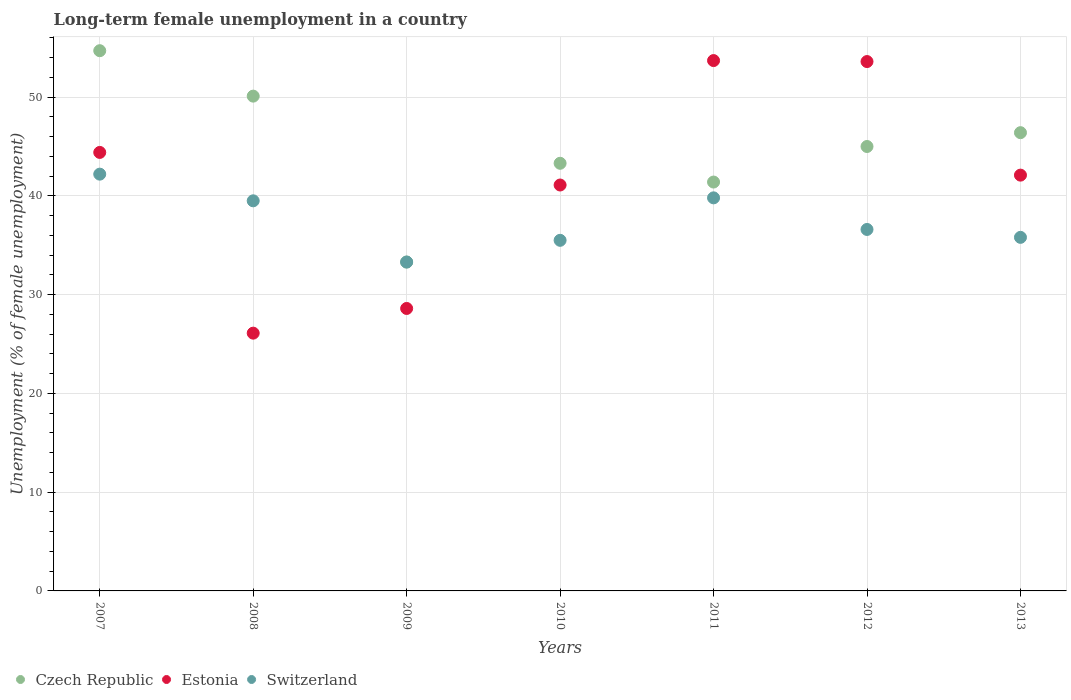How many different coloured dotlines are there?
Make the answer very short. 3. Is the number of dotlines equal to the number of legend labels?
Ensure brevity in your answer.  Yes. What is the percentage of long-term unemployed female population in Estonia in 2013?
Your response must be concise. 42.1. Across all years, what is the maximum percentage of long-term unemployed female population in Czech Republic?
Provide a succinct answer. 54.7. Across all years, what is the minimum percentage of long-term unemployed female population in Switzerland?
Provide a short and direct response. 33.3. In which year was the percentage of long-term unemployed female population in Estonia minimum?
Offer a terse response. 2008. What is the total percentage of long-term unemployed female population in Estonia in the graph?
Provide a succinct answer. 289.6. What is the difference between the percentage of long-term unemployed female population in Switzerland in 2009 and that in 2011?
Offer a terse response. -6.5. What is the difference between the percentage of long-term unemployed female population in Czech Republic in 2007 and the percentage of long-term unemployed female population in Switzerland in 2012?
Provide a succinct answer. 18.1. What is the average percentage of long-term unemployed female population in Czech Republic per year?
Make the answer very short. 44.89. In the year 2009, what is the difference between the percentage of long-term unemployed female population in Switzerland and percentage of long-term unemployed female population in Czech Republic?
Your answer should be compact. 0. In how many years, is the percentage of long-term unemployed female population in Estonia greater than 54 %?
Your answer should be very brief. 0. What is the ratio of the percentage of long-term unemployed female population in Czech Republic in 2010 to that in 2012?
Offer a very short reply. 0.96. What is the difference between the highest and the second highest percentage of long-term unemployed female population in Switzerland?
Provide a succinct answer. 2.4. What is the difference between the highest and the lowest percentage of long-term unemployed female population in Estonia?
Make the answer very short. 27.6. In how many years, is the percentage of long-term unemployed female population in Switzerland greater than the average percentage of long-term unemployed female population in Switzerland taken over all years?
Provide a succinct answer. 3. Is the percentage of long-term unemployed female population in Estonia strictly greater than the percentage of long-term unemployed female population in Switzerland over the years?
Provide a succinct answer. No. Is the percentage of long-term unemployed female population in Estonia strictly less than the percentage of long-term unemployed female population in Czech Republic over the years?
Give a very brief answer. No. How many years are there in the graph?
Keep it short and to the point. 7. Are the values on the major ticks of Y-axis written in scientific E-notation?
Offer a terse response. No. Does the graph contain any zero values?
Provide a succinct answer. No. Where does the legend appear in the graph?
Give a very brief answer. Bottom left. How many legend labels are there?
Offer a very short reply. 3. What is the title of the graph?
Make the answer very short. Long-term female unemployment in a country. What is the label or title of the X-axis?
Provide a succinct answer. Years. What is the label or title of the Y-axis?
Provide a succinct answer. Unemployment (% of female unemployment). What is the Unemployment (% of female unemployment) in Czech Republic in 2007?
Offer a very short reply. 54.7. What is the Unemployment (% of female unemployment) in Estonia in 2007?
Provide a succinct answer. 44.4. What is the Unemployment (% of female unemployment) of Switzerland in 2007?
Provide a short and direct response. 42.2. What is the Unemployment (% of female unemployment) in Czech Republic in 2008?
Offer a terse response. 50.1. What is the Unemployment (% of female unemployment) in Estonia in 2008?
Make the answer very short. 26.1. What is the Unemployment (% of female unemployment) in Switzerland in 2008?
Ensure brevity in your answer.  39.5. What is the Unemployment (% of female unemployment) in Czech Republic in 2009?
Keep it short and to the point. 33.3. What is the Unemployment (% of female unemployment) in Estonia in 2009?
Make the answer very short. 28.6. What is the Unemployment (% of female unemployment) in Switzerland in 2009?
Ensure brevity in your answer.  33.3. What is the Unemployment (% of female unemployment) in Czech Republic in 2010?
Provide a short and direct response. 43.3. What is the Unemployment (% of female unemployment) of Estonia in 2010?
Offer a very short reply. 41.1. What is the Unemployment (% of female unemployment) in Switzerland in 2010?
Keep it short and to the point. 35.5. What is the Unemployment (% of female unemployment) of Czech Republic in 2011?
Your answer should be very brief. 41.4. What is the Unemployment (% of female unemployment) of Estonia in 2011?
Ensure brevity in your answer.  53.7. What is the Unemployment (% of female unemployment) of Switzerland in 2011?
Offer a terse response. 39.8. What is the Unemployment (% of female unemployment) in Czech Republic in 2012?
Your answer should be compact. 45. What is the Unemployment (% of female unemployment) of Estonia in 2012?
Provide a short and direct response. 53.6. What is the Unemployment (% of female unemployment) of Switzerland in 2012?
Your answer should be very brief. 36.6. What is the Unemployment (% of female unemployment) of Czech Republic in 2013?
Offer a terse response. 46.4. What is the Unemployment (% of female unemployment) of Estonia in 2013?
Offer a very short reply. 42.1. What is the Unemployment (% of female unemployment) in Switzerland in 2013?
Your answer should be compact. 35.8. Across all years, what is the maximum Unemployment (% of female unemployment) of Czech Republic?
Provide a succinct answer. 54.7. Across all years, what is the maximum Unemployment (% of female unemployment) in Estonia?
Provide a short and direct response. 53.7. Across all years, what is the maximum Unemployment (% of female unemployment) in Switzerland?
Ensure brevity in your answer.  42.2. Across all years, what is the minimum Unemployment (% of female unemployment) in Czech Republic?
Provide a short and direct response. 33.3. Across all years, what is the minimum Unemployment (% of female unemployment) of Estonia?
Your answer should be compact. 26.1. Across all years, what is the minimum Unemployment (% of female unemployment) in Switzerland?
Your response must be concise. 33.3. What is the total Unemployment (% of female unemployment) in Czech Republic in the graph?
Your answer should be very brief. 314.2. What is the total Unemployment (% of female unemployment) in Estonia in the graph?
Ensure brevity in your answer.  289.6. What is the total Unemployment (% of female unemployment) of Switzerland in the graph?
Offer a terse response. 262.7. What is the difference between the Unemployment (% of female unemployment) in Czech Republic in 2007 and that in 2009?
Offer a very short reply. 21.4. What is the difference between the Unemployment (% of female unemployment) of Switzerland in 2007 and that in 2009?
Your response must be concise. 8.9. What is the difference between the Unemployment (% of female unemployment) of Czech Republic in 2007 and that in 2012?
Give a very brief answer. 9.7. What is the difference between the Unemployment (% of female unemployment) of Czech Republic in 2007 and that in 2013?
Offer a terse response. 8.3. What is the difference between the Unemployment (% of female unemployment) in Switzerland in 2008 and that in 2009?
Give a very brief answer. 6.2. What is the difference between the Unemployment (% of female unemployment) in Estonia in 2008 and that in 2010?
Provide a succinct answer. -15. What is the difference between the Unemployment (% of female unemployment) in Czech Republic in 2008 and that in 2011?
Offer a terse response. 8.7. What is the difference between the Unemployment (% of female unemployment) in Estonia in 2008 and that in 2011?
Provide a succinct answer. -27.6. What is the difference between the Unemployment (% of female unemployment) in Czech Republic in 2008 and that in 2012?
Offer a terse response. 5.1. What is the difference between the Unemployment (% of female unemployment) in Estonia in 2008 and that in 2012?
Make the answer very short. -27.5. What is the difference between the Unemployment (% of female unemployment) in Switzerland in 2008 and that in 2012?
Make the answer very short. 2.9. What is the difference between the Unemployment (% of female unemployment) in Estonia in 2009 and that in 2010?
Your answer should be compact. -12.5. What is the difference between the Unemployment (% of female unemployment) of Switzerland in 2009 and that in 2010?
Offer a terse response. -2.2. What is the difference between the Unemployment (% of female unemployment) in Czech Republic in 2009 and that in 2011?
Your answer should be very brief. -8.1. What is the difference between the Unemployment (% of female unemployment) of Estonia in 2009 and that in 2011?
Ensure brevity in your answer.  -25.1. What is the difference between the Unemployment (% of female unemployment) of Switzerland in 2009 and that in 2011?
Provide a succinct answer. -6.5. What is the difference between the Unemployment (% of female unemployment) of Estonia in 2009 and that in 2012?
Offer a very short reply. -25. What is the difference between the Unemployment (% of female unemployment) of Switzerland in 2009 and that in 2012?
Make the answer very short. -3.3. What is the difference between the Unemployment (% of female unemployment) of Czech Republic in 2009 and that in 2013?
Your response must be concise. -13.1. What is the difference between the Unemployment (% of female unemployment) of Estonia in 2009 and that in 2013?
Your answer should be compact. -13.5. What is the difference between the Unemployment (% of female unemployment) in Czech Republic in 2010 and that in 2011?
Provide a short and direct response. 1.9. What is the difference between the Unemployment (% of female unemployment) of Estonia in 2010 and that in 2011?
Your answer should be very brief. -12.6. What is the difference between the Unemployment (% of female unemployment) of Switzerland in 2010 and that in 2011?
Offer a terse response. -4.3. What is the difference between the Unemployment (% of female unemployment) of Switzerland in 2010 and that in 2012?
Keep it short and to the point. -1.1. What is the difference between the Unemployment (% of female unemployment) in Estonia in 2010 and that in 2013?
Give a very brief answer. -1. What is the difference between the Unemployment (% of female unemployment) of Switzerland in 2010 and that in 2013?
Your response must be concise. -0.3. What is the difference between the Unemployment (% of female unemployment) of Czech Republic in 2011 and that in 2012?
Keep it short and to the point. -3.6. What is the difference between the Unemployment (% of female unemployment) in Estonia in 2011 and that in 2012?
Your response must be concise. 0.1. What is the difference between the Unemployment (% of female unemployment) in Switzerland in 2011 and that in 2012?
Your answer should be compact. 3.2. What is the difference between the Unemployment (% of female unemployment) of Estonia in 2012 and that in 2013?
Provide a short and direct response. 11.5. What is the difference between the Unemployment (% of female unemployment) of Switzerland in 2012 and that in 2013?
Your response must be concise. 0.8. What is the difference between the Unemployment (% of female unemployment) of Czech Republic in 2007 and the Unemployment (% of female unemployment) of Estonia in 2008?
Offer a very short reply. 28.6. What is the difference between the Unemployment (% of female unemployment) in Estonia in 2007 and the Unemployment (% of female unemployment) in Switzerland in 2008?
Offer a very short reply. 4.9. What is the difference between the Unemployment (% of female unemployment) of Czech Republic in 2007 and the Unemployment (% of female unemployment) of Estonia in 2009?
Provide a succinct answer. 26.1. What is the difference between the Unemployment (% of female unemployment) in Czech Republic in 2007 and the Unemployment (% of female unemployment) in Switzerland in 2009?
Keep it short and to the point. 21.4. What is the difference between the Unemployment (% of female unemployment) in Czech Republic in 2007 and the Unemployment (% of female unemployment) in Switzerland in 2010?
Provide a succinct answer. 19.2. What is the difference between the Unemployment (% of female unemployment) in Estonia in 2007 and the Unemployment (% of female unemployment) in Switzerland in 2010?
Ensure brevity in your answer.  8.9. What is the difference between the Unemployment (% of female unemployment) in Czech Republic in 2007 and the Unemployment (% of female unemployment) in Estonia in 2011?
Your response must be concise. 1. What is the difference between the Unemployment (% of female unemployment) of Czech Republic in 2007 and the Unemployment (% of female unemployment) of Switzerland in 2011?
Provide a short and direct response. 14.9. What is the difference between the Unemployment (% of female unemployment) of Czech Republic in 2007 and the Unemployment (% of female unemployment) of Estonia in 2012?
Offer a terse response. 1.1. What is the difference between the Unemployment (% of female unemployment) in Czech Republic in 2007 and the Unemployment (% of female unemployment) in Switzerland in 2012?
Provide a short and direct response. 18.1. What is the difference between the Unemployment (% of female unemployment) in Czech Republic in 2008 and the Unemployment (% of female unemployment) in Estonia in 2009?
Provide a short and direct response. 21.5. What is the difference between the Unemployment (% of female unemployment) in Czech Republic in 2008 and the Unemployment (% of female unemployment) in Switzerland in 2009?
Your answer should be compact. 16.8. What is the difference between the Unemployment (% of female unemployment) of Estonia in 2008 and the Unemployment (% of female unemployment) of Switzerland in 2009?
Your response must be concise. -7.2. What is the difference between the Unemployment (% of female unemployment) in Czech Republic in 2008 and the Unemployment (% of female unemployment) in Estonia in 2010?
Provide a short and direct response. 9. What is the difference between the Unemployment (% of female unemployment) in Estonia in 2008 and the Unemployment (% of female unemployment) in Switzerland in 2010?
Keep it short and to the point. -9.4. What is the difference between the Unemployment (% of female unemployment) of Czech Republic in 2008 and the Unemployment (% of female unemployment) of Estonia in 2011?
Offer a very short reply. -3.6. What is the difference between the Unemployment (% of female unemployment) of Estonia in 2008 and the Unemployment (% of female unemployment) of Switzerland in 2011?
Make the answer very short. -13.7. What is the difference between the Unemployment (% of female unemployment) in Czech Republic in 2008 and the Unemployment (% of female unemployment) in Estonia in 2012?
Your answer should be very brief. -3.5. What is the difference between the Unemployment (% of female unemployment) in Czech Republic in 2008 and the Unemployment (% of female unemployment) in Switzerland in 2013?
Offer a very short reply. 14.3. What is the difference between the Unemployment (% of female unemployment) in Estonia in 2009 and the Unemployment (% of female unemployment) in Switzerland in 2010?
Offer a very short reply. -6.9. What is the difference between the Unemployment (% of female unemployment) of Czech Republic in 2009 and the Unemployment (% of female unemployment) of Estonia in 2011?
Your response must be concise. -20.4. What is the difference between the Unemployment (% of female unemployment) of Czech Republic in 2009 and the Unemployment (% of female unemployment) of Switzerland in 2011?
Provide a succinct answer. -6.5. What is the difference between the Unemployment (% of female unemployment) in Estonia in 2009 and the Unemployment (% of female unemployment) in Switzerland in 2011?
Your answer should be compact. -11.2. What is the difference between the Unemployment (% of female unemployment) in Czech Republic in 2009 and the Unemployment (% of female unemployment) in Estonia in 2012?
Ensure brevity in your answer.  -20.3. What is the difference between the Unemployment (% of female unemployment) of Czech Republic in 2009 and the Unemployment (% of female unemployment) of Switzerland in 2012?
Keep it short and to the point. -3.3. What is the difference between the Unemployment (% of female unemployment) in Czech Republic in 2009 and the Unemployment (% of female unemployment) in Switzerland in 2013?
Your answer should be compact. -2.5. What is the difference between the Unemployment (% of female unemployment) in Czech Republic in 2010 and the Unemployment (% of female unemployment) in Switzerland in 2011?
Offer a terse response. 3.5. What is the difference between the Unemployment (% of female unemployment) in Estonia in 2010 and the Unemployment (% of female unemployment) in Switzerland in 2011?
Make the answer very short. 1.3. What is the difference between the Unemployment (% of female unemployment) in Czech Republic in 2010 and the Unemployment (% of female unemployment) in Estonia in 2012?
Your response must be concise. -10.3. What is the difference between the Unemployment (% of female unemployment) in Czech Republic in 2010 and the Unemployment (% of female unemployment) in Switzerland in 2012?
Offer a very short reply. 6.7. What is the difference between the Unemployment (% of female unemployment) in Estonia in 2010 and the Unemployment (% of female unemployment) in Switzerland in 2012?
Provide a short and direct response. 4.5. What is the difference between the Unemployment (% of female unemployment) of Estonia in 2010 and the Unemployment (% of female unemployment) of Switzerland in 2013?
Provide a succinct answer. 5.3. What is the difference between the Unemployment (% of female unemployment) of Czech Republic in 2011 and the Unemployment (% of female unemployment) of Estonia in 2012?
Make the answer very short. -12.2. What is the difference between the Unemployment (% of female unemployment) of Estonia in 2011 and the Unemployment (% of female unemployment) of Switzerland in 2012?
Keep it short and to the point. 17.1. What is the difference between the Unemployment (% of female unemployment) of Estonia in 2011 and the Unemployment (% of female unemployment) of Switzerland in 2013?
Provide a short and direct response. 17.9. What is the difference between the Unemployment (% of female unemployment) in Czech Republic in 2012 and the Unemployment (% of female unemployment) in Switzerland in 2013?
Ensure brevity in your answer.  9.2. What is the difference between the Unemployment (% of female unemployment) of Estonia in 2012 and the Unemployment (% of female unemployment) of Switzerland in 2013?
Your answer should be very brief. 17.8. What is the average Unemployment (% of female unemployment) of Czech Republic per year?
Ensure brevity in your answer.  44.89. What is the average Unemployment (% of female unemployment) in Estonia per year?
Ensure brevity in your answer.  41.37. What is the average Unemployment (% of female unemployment) in Switzerland per year?
Offer a very short reply. 37.53. In the year 2008, what is the difference between the Unemployment (% of female unemployment) of Czech Republic and Unemployment (% of female unemployment) of Estonia?
Provide a succinct answer. 24. In the year 2010, what is the difference between the Unemployment (% of female unemployment) in Estonia and Unemployment (% of female unemployment) in Switzerland?
Offer a terse response. 5.6. In the year 2011, what is the difference between the Unemployment (% of female unemployment) in Czech Republic and Unemployment (% of female unemployment) in Estonia?
Keep it short and to the point. -12.3. In the year 2012, what is the difference between the Unemployment (% of female unemployment) in Czech Republic and Unemployment (% of female unemployment) in Estonia?
Your answer should be very brief. -8.6. In the year 2013, what is the difference between the Unemployment (% of female unemployment) of Czech Republic and Unemployment (% of female unemployment) of Switzerland?
Your answer should be very brief. 10.6. What is the ratio of the Unemployment (% of female unemployment) of Czech Republic in 2007 to that in 2008?
Your answer should be very brief. 1.09. What is the ratio of the Unemployment (% of female unemployment) of Estonia in 2007 to that in 2008?
Offer a very short reply. 1.7. What is the ratio of the Unemployment (% of female unemployment) in Switzerland in 2007 to that in 2008?
Provide a succinct answer. 1.07. What is the ratio of the Unemployment (% of female unemployment) in Czech Republic in 2007 to that in 2009?
Offer a very short reply. 1.64. What is the ratio of the Unemployment (% of female unemployment) in Estonia in 2007 to that in 2009?
Ensure brevity in your answer.  1.55. What is the ratio of the Unemployment (% of female unemployment) of Switzerland in 2007 to that in 2009?
Offer a very short reply. 1.27. What is the ratio of the Unemployment (% of female unemployment) in Czech Republic in 2007 to that in 2010?
Your response must be concise. 1.26. What is the ratio of the Unemployment (% of female unemployment) in Estonia in 2007 to that in 2010?
Your answer should be very brief. 1.08. What is the ratio of the Unemployment (% of female unemployment) in Switzerland in 2007 to that in 2010?
Your response must be concise. 1.19. What is the ratio of the Unemployment (% of female unemployment) in Czech Republic in 2007 to that in 2011?
Offer a very short reply. 1.32. What is the ratio of the Unemployment (% of female unemployment) in Estonia in 2007 to that in 2011?
Make the answer very short. 0.83. What is the ratio of the Unemployment (% of female unemployment) of Switzerland in 2007 to that in 2011?
Ensure brevity in your answer.  1.06. What is the ratio of the Unemployment (% of female unemployment) of Czech Republic in 2007 to that in 2012?
Your answer should be compact. 1.22. What is the ratio of the Unemployment (% of female unemployment) of Estonia in 2007 to that in 2012?
Keep it short and to the point. 0.83. What is the ratio of the Unemployment (% of female unemployment) of Switzerland in 2007 to that in 2012?
Your answer should be compact. 1.15. What is the ratio of the Unemployment (% of female unemployment) of Czech Republic in 2007 to that in 2013?
Ensure brevity in your answer.  1.18. What is the ratio of the Unemployment (% of female unemployment) of Estonia in 2007 to that in 2013?
Provide a short and direct response. 1.05. What is the ratio of the Unemployment (% of female unemployment) of Switzerland in 2007 to that in 2013?
Your answer should be compact. 1.18. What is the ratio of the Unemployment (% of female unemployment) of Czech Republic in 2008 to that in 2009?
Provide a short and direct response. 1.5. What is the ratio of the Unemployment (% of female unemployment) in Estonia in 2008 to that in 2009?
Your response must be concise. 0.91. What is the ratio of the Unemployment (% of female unemployment) of Switzerland in 2008 to that in 2009?
Make the answer very short. 1.19. What is the ratio of the Unemployment (% of female unemployment) in Czech Republic in 2008 to that in 2010?
Provide a short and direct response. 1.16. What is the ratio of the Unemployment (% of female unemployment) in Estonia in 2008 to that in 2010?
Your response must be concise. 0.64. What is the ratio of the Unemployment (% of female unemployment) in Switzerland in 2008 to that in 2010?
Ensure brevity in your answer.  1.11. What is the ratio of the Unemployment (% of female unemployment) in Czech Republic in 2008 to that in 2011?
Your answer should be very brief. 1.21. What is the ratio of the Unemployment (% of female unemployment) in Estonia in 2008 to that in 2011?
Ensure brevity in your answer.  0.49. What is the ratio of the Unemployment (% of female unemployment) in Switzerland in 2008 to that in 2011?
Make the answer very short. 0.99. What is the ratio of the Unemployment (% of female unemployment) of Czech Republic in 2008 to that in 2012?
Your answer should be compact. 1.11. What is the ratio of the Unemployment (% of female unemployment) of Estonia in 2008 to that in 2012?
Offer a very short reply. 0.49. What is the ratio of the Unemployment (% of female unemployment) of Switzerland in 2008 to that in 2012?
Offer a terse response. 1.08. What is the ratio of the Unemployment (% of female unemployment) in Czech Republic in 2008 to that in 2013?
Offer a terse response. 1.08. What is the ratio of the Unemployment (% of female unemployment) of Estonia in 2008 to that in 2013?
Your answer should be very brief. 0.62. What is the ratio of the Unemployment (% of female unemployment) in Switzerland in 2008 to that in 2013?
Your response must be concise. 1.1. What is the ratio of the Unemployment (% of female unemployment) in Czech Republic in 2009 to that in 2010?
Make the answer very short. 0.77. What is the ratio of the Unemployment (% of female unemployment) of Estonia in 2009 to that in 2010?
Provide a short and direct response. 0.7. What is the ratio of the Unemployment (% of female unemployment) in Switzerland in 2009 to that in 2010?
Offer a very short reply. 0.94. What is the ratio of the Unemployment (% of female unemployment) in Czech Republic in 2009 to that in 2011?
Your response must be concise. 0.8. What is the ratio of the Unemployment (% of female unemployment) of Estonia in 2009 to that in 2011?
Make the answer very short. 0.53. What is the ratio of the Unemployment (% of female unemployment) of Switzerland in 2009 to that in 2011?
Keep it short and to the point. 0.84. What is the ratio of the Unemployment (% of female unemployment) in Czech Republic in 2009 to that in 2012?
Keep it short and to the point. 0.74. What is the ratio of the Unemployment (% of female unemployment) in Estonia in 2009 to that in 2012?
Your answer should be very brief. 0.53. What is the ratio of the Unemployment (% of female unemployment) of Switzerland in 2009 to that in 2012?
Offer a very short reply. 0.91. What is the ratio of the Unemployment (% of female unemployment) in Czech Republic in 2009 to that in 2013?
Your response must be concise. 0.72. What is the ratio of the Unemployment (% of female unemployment) of Estonia in 2009 to that in 2013?
Give a very brief answer. 0.68. What is the ratio of the Unemployment (% of female unemployment) in Switzerland in 2009 to that in 2013?
Provide a succinct answer. 0.93. What is the ratio of the Unemployment (% of female unemployment) of Czech Republic in 2010 to that in 2011?
Your response must be concise. 1.05. What is the ratio of the Unemployment (% of female unemployment) in Estonia in 2010 to that in 2011?
Provide a short and direct response. 0.77. What is the ratio of the Unemployment (% of female unemployment) of Switzerland in 2010 to that in 2011?
Give a very brief answer. 0.89. What is the ratio of the Unemployment (% of female unemployment) of Czech Republic in 2010 to that in 2012?
Give a very brief answer. 0.96. What is the ratio of the Unemployment (% of female unemployment) of Estonia in 2010 to that in 2012?
Your answer should be very brief. 0.77. What is the ratio of the Unemployment (% of female unemployment) of Switzerland in 2010 to that in 2012?
Offer a very short reply. 0.97. What is the ratio of the Unemployment (% of female unemployment) of Czech Republic in 2010 to that in 2013?
Ensure brevity in your answer.  0.93. What is the ratio of the Unemployment (% of female unemployment) of Estonia in 2010 to that in 2013?
Your response must be concise. 0.98. What is the ratio of the Unemployment (% of female unemployment) in Switzerland in 2010 to that in 2013?
Offer a very short reply. 0.99. What is the ratio of the Unemployment (% of female unemployment) in Estonia in 2011 to that in 2012?
Give a very brief answer. 1. What is the ratio of the Unemployment (% of female unemployment) of Switzerland in 2011 to that in 2012?
Ensure brevity in your answer.  1.09. What is the ratio of the Unemployment (% of female unemployment) in Czech Republic in 2011 to that in 2013?
Your response must be concise. 0.89. What is the ratio of the Unemployment (% of female unemployment) in Estonia in 2011 to that in 2013?
Your answer should be very brief. 1.28. What is the ratio of the Unemployment (% of female unemployment) in Switzerland in 2011 to that in 2013?
Ensure brevity in your answer.  1.11. What is the ratio of the Unemployment (% of female unemployment) in Czech Republic in 2012 to that in 2013?
Provide a short and direct response. 0.97. What is the ratio of the Unemployment (% of female unemployment) of Estonia in 2012 to that in 2013?
Keep it short and to the point. 1.27. What is the ratio of the Unemployment (% of female unemployment) of Switzerland in 2012 to that in 2013?
Your answer should be compact. 1.02. What is the difference between the highest and the second highest Unemployment (% of female unemployment) of Czech Republic?
Make the answer very short. 4.6. What is the difference between the highest and the second highest Unemployment (% of female unemployment) of Estonia?
Give a very brief answer. 0.1. What is the difference between the highest and the lowest Unemployment (% of female unemployment) of Czech Republic?
Provide a succinct answer. 21.4. What is the difference between the highest and the lowest Unemployment (% of female unemployment) of Estonia?
Keep it short and to the point. 27.6. 